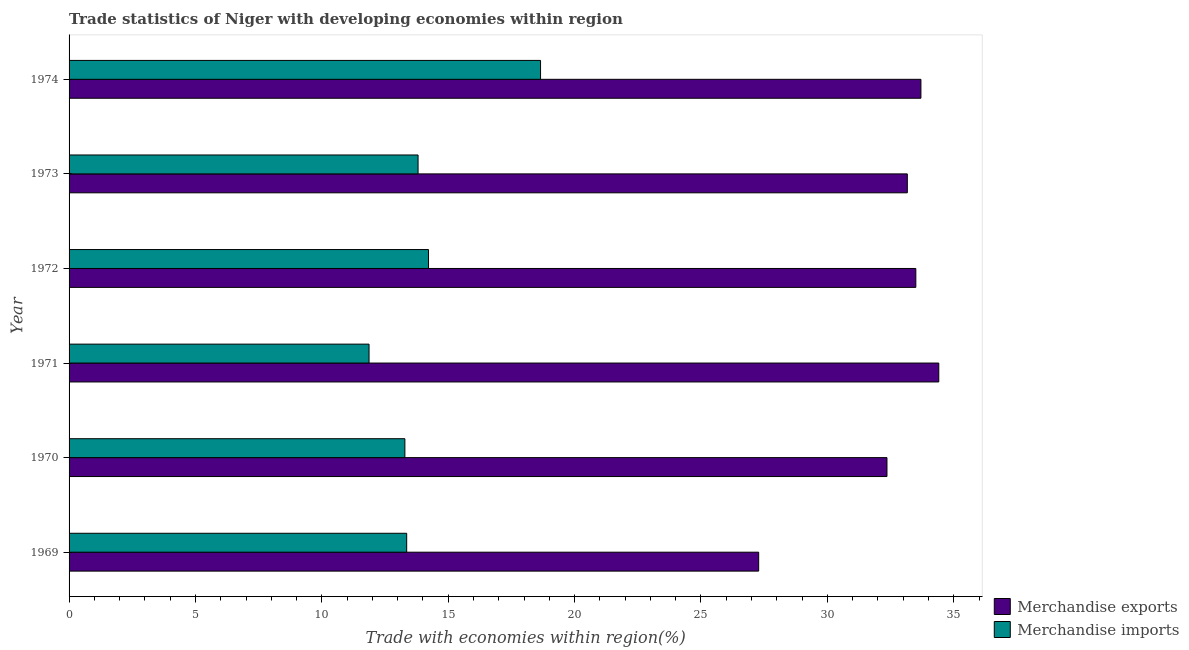How many different coloured bars are there?
Make the answer very short. 2. How many groups of bars are there?
Ensure brevity in your answer.  6. Are the number of bars per tick equal to the number of legend labels?
Provide a succinct answer. Yes. How many bars are there on the 3rd tick from the top?
Your answer should be very brief. 2. What is the merchandise exports in 1971?
Your response must be concise. 34.41. Across all years, what is the maximum merchandise exports?
Give a very brief answer. 34.41. Across all years, what is the minimum merchandise exports?
Your answer should be compact. 27.28. In which year was the merchandise imports maximum?
Make the answer very short. 1974. What is the total merchandise imports in the graph?
Your response must be concise. 85.19. What is the difference between the merchandise exports in 1969 and that in 1973?
Give a very brief answer. -5.88. What is the difference between the merchandise imports in 1971 and the merchandise exports in 1970?
Offer a terse response. -20.49. What is the average merchandise imports per year?
Make the answer very short. 14.2. In the year 1972, what is the difference between the merchandise exports and merchandise imports?
Your answer should be very brief. 19.28. In how many years, is the merchandise exports greater than 31 %?
Provide a short and direct response. 5. What is the ratio of the merchandise exports in 1972 to that in 1973?
Your answer should be very brief. 1.01. Is the merchandise imports in 1970 less than that in 1974?
Offer a terse response. Yes. Is the difference between the merchandise exports in 1971 and 1974 greater than the difference between the merchandise imports in 1971 and 1974?
Provide a short and direct response. Yes. What is the difference between the highest and the second highest merchandise imports?
Ensure brevity in your answer.  4.43. What is the difference between the highest and the lowest merchandise exports?
Keep it short and to the point. 7.13. In how many years, is the merchandise exports greater than the average merchandise exports taken over all years?
Your answer should be compact. 4. What does the 2nd bar from the top in 1973 represents?
Your answer should be compact. Merchandise exports. What does the 2nd bar from the bottom in 1974 represents?
Offer a very short reply. Merchandise imports. How many years are there in the graph?
Your response must be concise. 6. What is the difference between two consecutive major ticks on the X-axis?
Offer a very short reply. 5. Are the values on the major ticks of X-axis written in scientific E-notation?
Your answer should be compact. No. Does the graph contain grids?
Provide a succinct answer. No. How are the legend labels stacked?
Provide a short and direct response. Vertical. What is the title of the graph?
Offer a terse response. Trade statistics of Niger with developing economies within region. Does "Secondary school" appear as one of the legend labels in the graph?
Your answer should be compact. No. What is the label or title of the X-axis?
Ensure brevity in your answer.  Trade with economies within region(%). What is the Trade with economies within region(%) of Merchandise exports in 1969?
Provide a short and direct response. 27.28. What is the Trade with economies within region(%) of Merchandise imports in 1969?
Provide a succinct answer. 13.36. What is the Trade with economies within region(%) in Merchandise exports in 1970?
Make the answer very short. 32.36. What is the Trade with economies within region(%) of Merchandise imports in 1970?
Ensure brevity in your answer.  13.29. What is the Trade with economies within region(%) of Merchandise exports in 1971?
Make the answer very short. 34.41. What is the Trade with economies within region(%) in Merchandise imports in 1971?
Ensure brevity in your answer.  11.87. What is the Trade with economies within region(%) in Merchandise exports in 1972?
Provide a short and direct response. 33.5. What is the Trade with economies within region(%) of Merchandise imports in 1972?
Give a very brief answer. 14.22. What is the Trade with economies within region(%) of Merchandise exports in 1973?
Offer a very short reply. 33.16. What is the Trade with economies within region(%) in Merchandise imports in 1973?
Provide a short and direct response. 13.81. What is the Trade with economies within region(%) in Merchandise exports in 1974?
Keep it short and to the point. 33.7. What is the Trade with economies within region(%) of Merchandise imports in 1974?
Keep it short and to the point. 18.65. Across all years, what is the maximum Trade with economies within region(%) of Merchandise exports?
Your answer should be compact. 34.41. Across all years, what is the maximum Trade with economies within region(%) in Merchandise imports?
Give a very brief answer. 18.65. Across all years, what is the minimum Trade with economies within region(%) of Merchandise exports?
Your answer should be compact. 27.28. Across all years, what is the minimum Trade with economies within region(%) in Merchandise imports?
Offer a terse response. 11.87. What is the total Trade with economies within region(%) in Merchandise exports in the graph?
Offer a very short reply. 194.42. What is the total Trade with economies within region(%) of Merchandise imports in the graph?
Provide a short and direct response. 85.19. What is the difference between the Trade with economies within region(%) in Merchandise exports in 1969 and that in 1970?
Ensure brevity in your answer.  -5.08. What is the difference between the Trade with economies within region(%) of Merchandise imports in 1969 and that in 1970?
Your answer should be compact. 0.07. What is the difference between the Trade with economies within region(%) of Merchandise exports in 1969 and that in 1971?
Ensure brevity in your answer.  -7.13. What is the difference between the Trade with economies within region(%) in Merchandise imports in 1969 and that in 1971?
Offer a very short reply. 1.49. What is the difference between the Trade with economies within region(%) of Merchandise exports in 1969 and that in 1972?
Offer a very short reply. -6.22. What is the difference between the Trade with economies within region(%) of Merchandise imports in 1969 and that in 1972?
Give a very brief answer. -0.86. What is the difference between the Trade with economies within region(%) in Merchandise exports in 1969 and that in 1973?
Offer a terse response. -5.88. What is the difference between the Trade with economies within region(%) of Merchandise imports in 1969 and that in 1973?
Ensure brevity in your answer.  -0.45. What is the difference between the Trade with economies within region(%) of Merchandise exports in 1969 and that in 1974?
Your answer should be compact. -6.42. What is the difference between the Trade with economies within region(%) of Merchandise imports in 1969 and that in 1974?
Offer a very short reply. -5.3. What is the difference between the Trade with economies within region(%) of Merchandise exports in 1970 and that in 1971?
Your answer should be compact. -2.05. What is the difference between the Trade with economies within region(%) of Merchandise imports in 1970 and that in 1971?
Offer a terse response. 1.42. What is the difference between the Trade with economies within region(%) of Merchandise exports in 1970 and that in 1972?
Give a very brief answer. -1.14. What is the difference between the Trade with economies within region(%) in Merchandise imports in 1970 and that in 1972?
Make the answer very short. -0.94. What is the difference between the Trade with economies within region(%) of Merchandise exports in 1970 and that in 1973?
Your response must be concise. -0.81. What is the difference between the Trade with economies within region(%) of Merchandise imports in 1970 and that in 1973?
Offer a terse response. -0.52. What is the difference between the Trade with economies within region(%) of Merchandise exports in 1970 and that in 1974?
Your answer should be very brief. -1.34. What is the difference between the Trade with economies within region(%) in Merchandise imports in 1970 and that in 1974?
Offer a very short reply. -5.37. What is the difference between the Trade with economies within region(%) of Merchandise exports in 1971 and that in 1972?
Your answer should be very brief. 0.91. What is the difference between the Trade with economies within region(%) of Merchandise imports in 1971 and that in 1972?
Offer a terse response. -2.35. What is the difference between the Trade with economies within region(%) of Merchandise exports in 1971 and that in 1973?
Your answer should be very brief. 1.24. What is the difference between the Trade with economies within region(%) in Merchandise imports in 1971 and that in 1973?
Give a very brief answer. -1.94. What is the difference between the Trade with economies within region(%) in Merchandise exports in 1971 and that in 1974?
Your response must be concise. 0.71. What is the difference between the Trade with economies within region(%) in Merchandise imports in 1971 and that in 1974?
Your response must be concise. -6.78. What is the difference between the Trade with economies within region(%) of Merchandise exports in 1972 and that in 1973?
Offer a terse response. 0.34. What is the difference between the Trade with economies within region(%) of Merchandise imports in 1972 and that in 1973?
Provide a short and direct response. 0.41. What is the difference between the Trade with economies within region(%) in Merchandise exports in 1972 and that in 1974?
Your answer should be compact. -0.2. What is the difference between the Trade with economies within region(%) in Merchandise imports in 1972 and that in 1974?
Offer a very short reply. -4.43. What is the difference between the Trade with economies within region(%) in Merchandise exports in 1973 and that in 1974?
Your answer should be compact. -0.54. What is the difference between the Trade with economies within region(%) in Merchandise imports in 1973 and that in 1974?
Provide a short and direct response. -4.85. What is the difference between the Trade with economies within region(%) of Merchandise exports in 1969 and the Trade with economies within region(%) of Merchandise imports in 1970?
Provide a short and direct response. 14. What is the difference between the Trade with economies within region(%) in Merchandise exports in 1969 and the Trade with economies within region(%) in Merchandise imports in 1971?
Offer a terse response. 15.41. What is the difference between the Trade with economies within region(%) in Merchandise exports in 1969 and the Trade with economies within region(%) in Merchandise imports in 1972?
Provide a succinct answer. 13.06. What is the difference between the Trade with economies within region(%) of Merchandise exports in 1969 and the Trade with economies within region(%) of Merchandise imports in 1973?
Your response must be concise. 13.47. What is the difference between the Trade with economies within region(%) in Merchandise exports in 1969 and the Trade with economies within region(%) in Merchandise imports in 1974?
Provide a succinct answer. 8.63. What is the difference between the Trade with economies within region(%) of Merchandise exports in 1970 and the Trade with economies within region(%) of Merchandise imports in 1971?
Provide a succinct answer. 20.49. What is the difference between the Trade with economies within region(%) of Merchandise exports in 1970 and the Trade with economies within region(%) of Merchandise imports in 1972?
Provide a short and direct response. 18.14. What is the difference between the Trade with economies within region(%) in Merchandise exports in 1970 and the Trade with economies within region(%) in Merchandise imports in 1973?
Provide a short and direct response. 18.55. What is the difference between the Trade with economies within region(%) in Merchandise exports in 1970 and the Trade with economies within region(%) in Merchandise imports in 1974?
Offer a very short reply. 13.71. What is the difference between the Trade with economies within region(%) in Merchandise exports in 1971 and the Trade with economies within region(%) in Merchandise imports in 1972?
Provide a succinct answer. 20.19. What is the difference between the Trade with economies within region(%) in Merchandise exports in 1971 and the Trade with economies within region(%) in Merchandise imports in 1973?
Give a very brief answer. 20.6. What is the difference between the Trade with economies within region(%) of Merchandise exports in 1971 and the Trade with economies within region(%) of Merchandise imports in 1974?
Keep it short and to the point. 15.76. What is the difference between the Trade with economies within region(%) of Merchandise exports in 1972 and the Trade with economies within region(%) of Merchandise imports in 1973?
Offer a terse response. 19.69. What is the difference between the Trade with economies within region(%) in Merchandise exports in 1972 and the Trade with economies within region(%) in Merchandise imports in 1974?
Keep it short and to the point. 14.85. What is the difference between the Trade with economies within region(%) in Merchandise exports in 1973 and the Trade with economies within region(%) in Merchandise imports in 1974?
Keep it short and to the point. 14.51. What is the average Trade with economies within region(%) of Merchandise exports per year?
Make the answer very short. 32.4. What is the average Trade with economies within region(%) of Merchandise imports per year?
Provide a succinct answer. 14.2. In the year 1969, what is the difference between the Trade with economies within region(%) of Merchandise exports and Trade with economies within region(%) of Merchandise imports?
Your answer should be compact. 13.93. In the year 1970, what is the difference between the Trade with economies within region(%) in Merchandise exports and Trade with economies within region(%) in Merchandise imports?
Your answer should be compact. 19.07. In the year 1971, what is the difference between the Trade with economies within region(%) of Merchandise exports and Trade with economies within region(%) of Merchandise imports?
Offer a very short reply. 22.54. In the year 1972, what is the difference between the Trade with economies within region(%) in Merchandise exports and Trade with economies within region(%) in Merchandise imports?
Make the answer very short. 19.28. In the year 1973, what is the difference between the Trade with economies within region(%) in Merchandise exports and Trade with economies within region(%) in Merchandise imports?
Your answer should be very brief. 19.36. In the year 1974, what is the difference between the Trade with economies within region(%) in Merchandise exports and Trade with economies within region(%) in Merchandise imports?
Give a very brief answer. 15.05. What is the ratio of the Trade with economies within region(%) of Merchandise exports in 1969 to that in 1970?
Your answer should be compact. 0.84. What is the ratio of the Trade with economies within region(%) in Merchandise imports in 1969 to that in 1970?
Your answer should be compact. 1.01. What is the ratio of the Trade with economies within region(%) in Merchandise exports in 1969 to that in 1971?
Ensure brevity in your answer.  0.79. What is the ratio of the Trade with economies within region(%) of Merchandise imports in 1969 to that in 1971?
Offer a terse response. 1.13. What is the ratio of the Trade with economies within region(%) of Merchandise exports in 1969 to that in 1972?
Give a very brief answer. 0.81. What is the ratio of the Trade with economies within region(%) in Merchandise imports in 1969 to that in 1972?
Give a very brief answer. 0.94. What is the ratio of the Trade with economies within region(%) of Merchandise exports in 1969 to that in 1973?
Offer a very short reply. 0.82. What is the ratio of the Trade with economies within region(%) in Merchandise imports in 1969 to that in 1973?
Offer a terse response. 0.97. What is the ratio of the Trade with economies within region(%) in Merchandise exports in 1969 to that in 1974?
Give a very brief answer. 0.81. What is the ratio of the Trade with economies within region(%) of Merchandise imports in 1969 to that in 1974?
Offer a terse response. 0.72. What is the ratio of the Trade with economies within region(%) in Merchandise exports in 1970 to that in 1971?
Give a very brief answer. 0.94. What is the ratio of the Trade with economies within region(%) in Merchandise imports in 1970 to that in 1971?
Keep it short and to the point. 1.12. What is the ratio of the Trade with economies within region(%) of Merchandise exports in 1970 to that in 1972?
Offer a very short reply. 0.97. What is the ratio of the Trade with economies within region(%) of Merchandise imports in 1970 to that in 1972?
Offer a terse response. 0.93. What is the ratio of the Trade with economies within region(%) in Merchandise exports in 1970 to that in 1973?
Give a very brief answer. 0.98. What is the ratio of the Trade with economies within region(%) of Merchandise imports in 1970 to that in 1973?
Give a very brief answer. 0.96. What is the ratio of the Trade with economies within region(%) in Merchandise exports in 1970 to that in 1974?
Make the answer very short. 0.96. What is the ratio of the Trade with economies within region(%) in Merchandise imports in 1970 to that in 1974?
Keep it short and to the point. 0.71. What is the ratio of the Trade with economies within region(%) of Merchandise exports in 1971 to that in 1972?
Offer a very short reply. 1.03. What is the ratio of the Trade with economies within region(%) in Merchandise imports in 1971 to that in 1972?
Your response must be concise. 0.83. What is the ratio of the Trade with economies within region(%) in Merchandise exports in 1971 to that in 1973?
Make the answer very short. 1.04. What is the ratio of the Trade with economies within region(%) in Merchandise imports in 1971 to that in 1973?
Give a very brief answer. 0.86. What is the ratio of the Trade with economies within region(%) of Merchandise exports in 1971 to that in 1974?
Keep it short and to the point. 1.02. What is the ratio of the Trade with economies within region(%) of Merchandise imports in 1971 to that in 1974?
Your answer should be very brief. 0.64. What is the ratio of the Trade with economies within region(%) in Merchandise imports in 1972 to that in 1973?
Your answer should be very brief. 1.03. What is the ratio of the Trade with economies within region(%) of Merchandise exports in 1972 to that in 1974?
Your answer should be very brief. 0.99. What is the ratio of the Trade with economies within region(%) of Merchandise imports in 1972 to that in 1974?
Your response must be concise. 0.76. What is the ratio of the Trade with economies within region(%) of Merchandise exports in 1973 to that in 1974?
Your answer should be very brief. 0.98. What is the ratio of the Trade with economies within region(%) in Merchandise imports in 1973 to that in 1974?
Keep it short and to the point. 0.74. What is the difference between the highest and the second highest Trade with economies within region(%) of Merchandise exports?
Your response must be concise. 0.71. What is the difference between the highest and the second highest Trade with economies within region(%) in Merchandise imports?
Your response must be concise. 4.43. What is the difference between the highest and the lowest Trade with economies within region(%) in Merchandise exports?
Make the answer very short. 7.13. What is the difference between the highest and the lowest Trade with economies within region(%) of Merchandise imports?
Your answer should be compact. 6.78. 